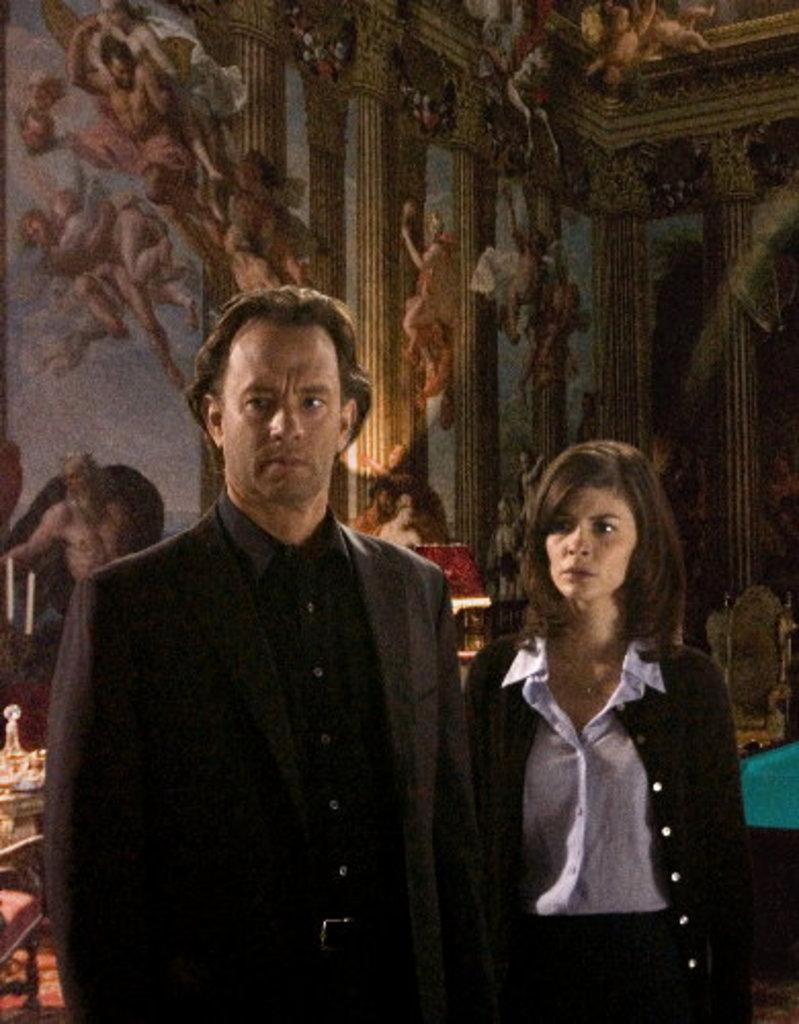Describe this image in one or two sentences. In this image we can see two people standing and also we can see some design on the wall, there are some chairs and other objects on the floor. 